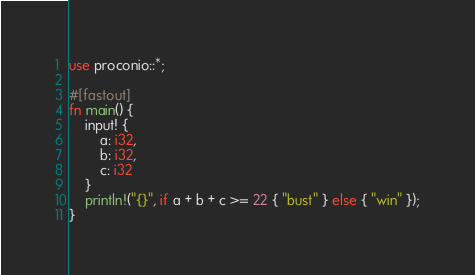Convert code to text. <code><loc_0><loc_0><loc_500><loc_500><_Rust_>use proconio::*;

#[fastout]
fn main() {
    input! {
        a: i32,
        b: i32,
        c: i32
    }
    println!("{}", if a + b + c >= 22 { "bust" } else { "win" });
}
</code> 